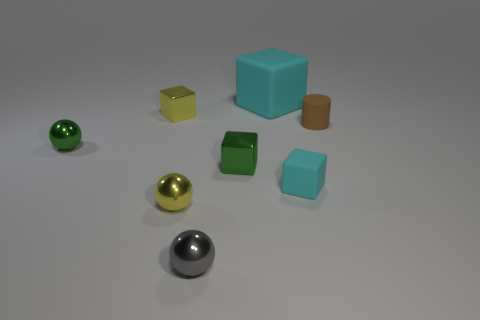How many blocks are cyan rubber objects or brown things?
Your answer should be very brief. 2. There is a small metallic object that is to the right of the gray ball in front of the large cyan object; how many tiny cubes are on the right side of it?
Ensure brevity in your answer.  1. There is a green object that is the same shape as the tiny gray object; what is it made of?
Make the answer very short. Metal. What color is the rubber thing behind the brown rubber thing?
Ensure brevity in your answer.  Cyan. Is the material of the brown cylinder the same as the cyan block that is behind the brown cylinder?
Offer a very short reply. Yes. What is the material of the yellow sphere?
Your response must be concise. Metal. There is a small gray thing that is the same material as the small yellow cube; what is its shape?
Offer a very short reply. Sphere. What number of other objects are there of the same shape as the small cyan object?
Your answer should be very brief. 3. There is a tiny cyan thing; how many cyan blocks are in front of it?
Your answer should be compact. 0. Does the green thing to the left of the small gray metallic sphere have the same size as the thing behind the small yellow metal cube?
Offer a terse response. No. 